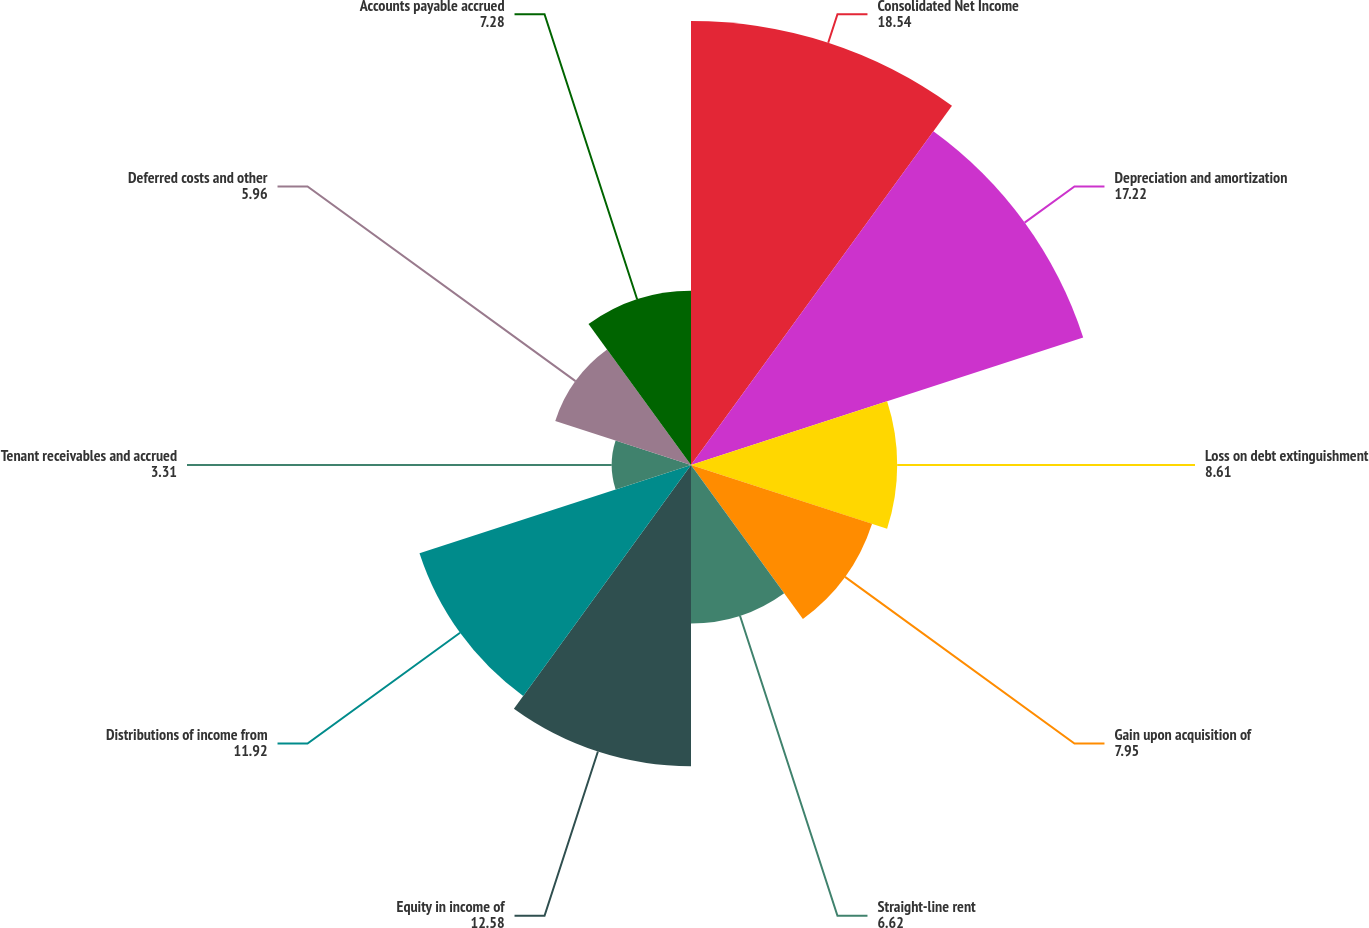Convert chart to OTSL. <chart><loc_0><loc_0><loc_500><loc_500><pie_chart><fcel>Consolidated Net Income<fcel>Depreciation and amortization<fcel>Loss on debt extinguishment<fcel>Gain upon acquisition of<fcel>Straight-line rent<fcel>Equity in income of<fcel>Distributions of income from<fcel>Tenant receivables and accrued<fcel>Deferred costs and other<fcel>Accounts payable accrued<nl><fcel>18.54%<fcel>17.22%<fcel>8.61%<fcel>7.95%<fcel>6.62%<fcel>12.58%<fcel>11.92%<fcel>3.31%<fcel>5.96%<fcel>7.28%<nl></chart> 